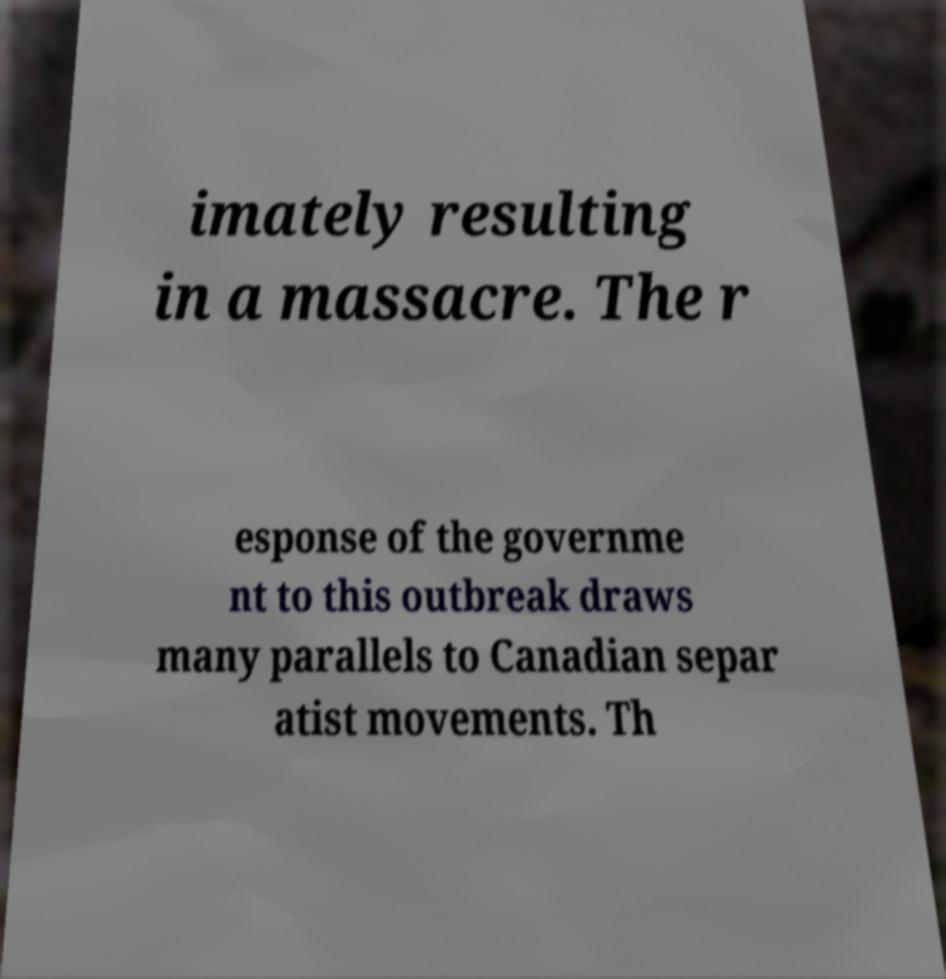For documentation purposes, I need the text within this image transcribed. Could you provide that? imately resulting in a massacre. The r esponse of the governme nt to this outbreak draws many parallels to Canadian separ atist movements. Th 